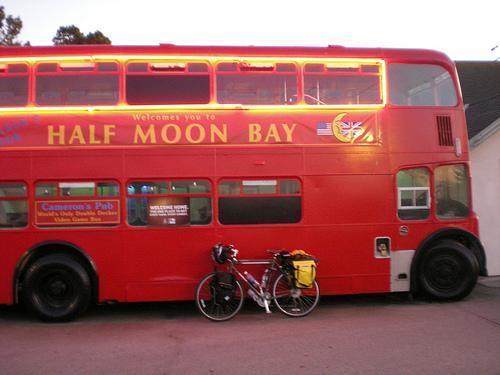How many bicycles are shown?
Give a very brief answer. 1. 